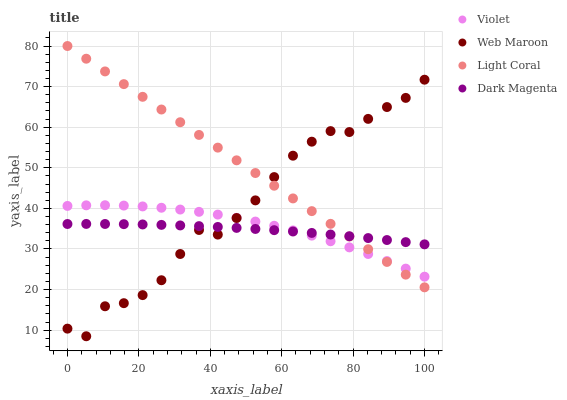Does Dark Magenta have the minimum area under the curve?
Answer yes or no. Yes. Does Light Coral have the maximum area under the curve?
Answer yes or no. Yes. Does Web Maroon have the minimum area under the curve?
Answer yes or no. No. Does Web Maroon have the maximum area under the curve?
Answer yes or no. No. Is Light Coral the smoothest?
Answer yes or no. Yes. Is Web Maroon the roughest?
Answer yes or no. Yes. Is Dark Magenta the smoothest?
Answer yes or no. No. Is Dark Magenta the roughest?
Answer yes or no. No. Does Web Maroon have the lowest value?
Answer yes or no. Yes. Does Dark Magenta have the lowest value?
Answer yes or no. No. Does Light Coral have the highest value?
Answer yes or no. Yes. Does Web Maroon have the highest value?
Answer yes or no. No. Does Violet intersect Dark Magenta?
Answer yes or no. Yes. Is Violet less than Dark Magenta?
Answer yes or no. No. Is Violet greater than Dark Magenta?
Answer yes or no. No. 